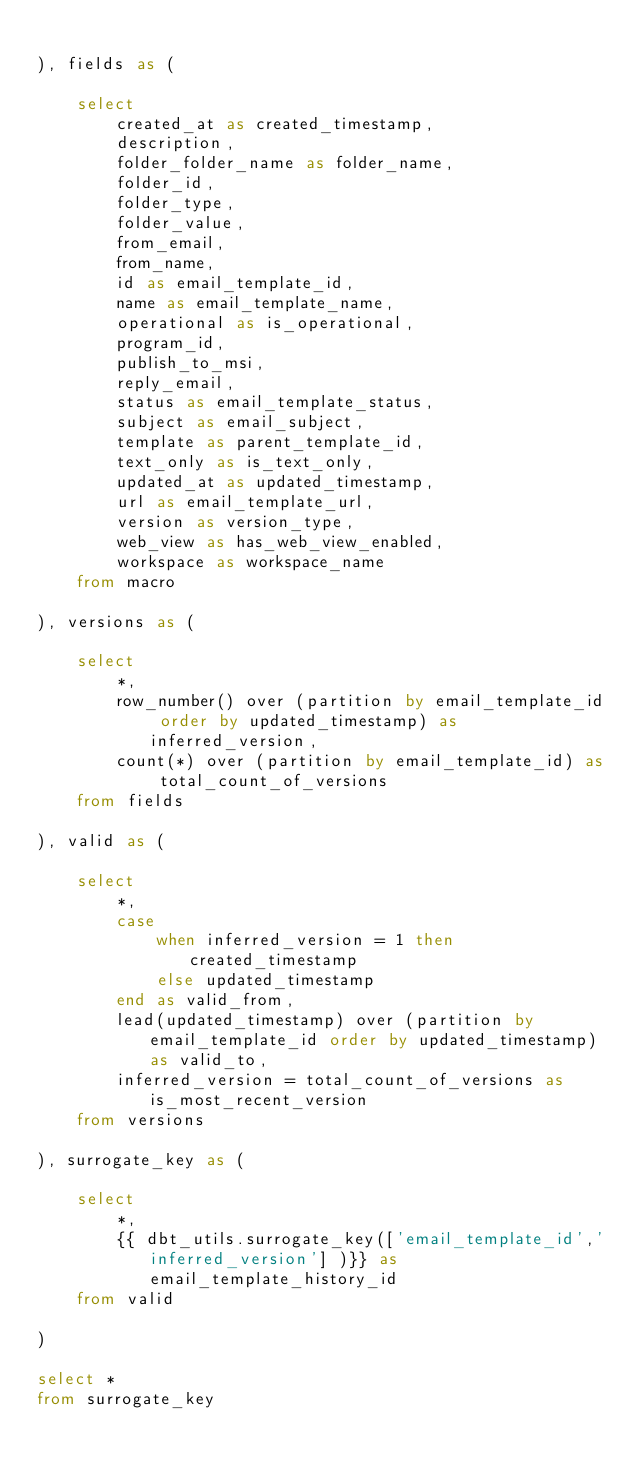Convert code to text. <code><loc_0><loc_0><loc_500><loc_500><_SQL_>
), fields as (

    select 
        created_at as created_timestamp,
        description,
        folder_folder_name as folder_name,
        folder_id,
        folder_type,
        folder_value,
        from_email,
        from_name,
        id as email_template_id,
        name as email_template_name,
        operational as is_operational,
        program_id,
        publish_to_msi,
        reply_email,
        status as email_template_status,
        subject as email_subject,
        template as parent_template_id,
        text_only as is_text_only,
        updated_at as updated_timestamp,
        url as email_template_url,
        version as version_type,
        web_view as has_web_view_enabled,
        workspace as workspace_name
    from macro

), versions as (

    select  
        *,
        row_number() over (partition by email_template_id order by updated_timestamp) as inferred_version,
        count(*) over (partition by email_template_id) as total_count_of_versions
    from fields

), valid as (

    select 
        *, 
        case
            when inferred_version = 1 then created_timestamp
            else updated_timestamp
        end as valid_from,
        lead(updated_timestamp) over (partition by email_template_id order by updated_timestamp) as valid_to,
        inferred_version = total_count_of_versions as is_most_recent_version
    from versions

), surrogate_key as (

    select 
        *,
        {{ dbt_utils.surrogate_key(['email_template_id','inferred_version'] )}} as email_template_history_id
    from valid

)

select *
from surrogate_key



</code> 